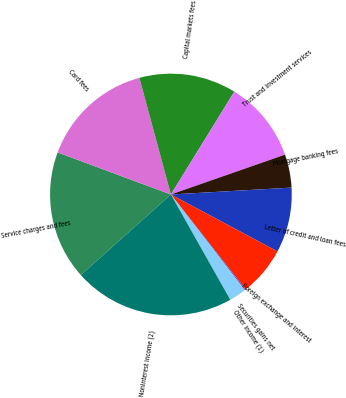<chart> <loc_0><loc_0><loc_500><loc_500><pie_chart><fcel>Service charges and fees<fcel>Card fees<fcel>Capital markets fees<fcel>Trust and investment services<fcel>Mortgage banking fees<fcel>Letter of credit and loan fees<fcel>Foreign exchange and interest<fcel>Securities gains net<fcel>Other income (1)<fcel>Noninterest income (2)<nl><fcel>17.28%<fcel>15.14%<fcel>13.0%<fcel>10.86%<fcel>4.44%<fcel>8.72%<fcel>6.58%<fcel>0.15%<fcel>2.29%<fcel>21.56%<nl></chart> 